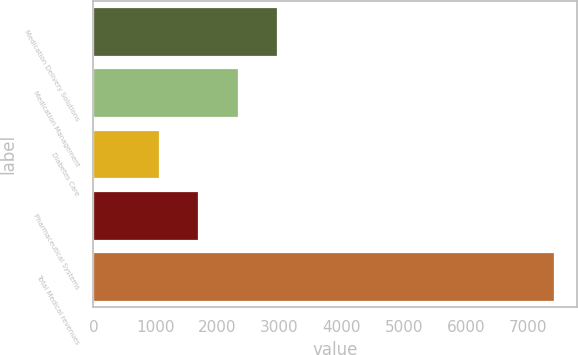Convert chart to OTSL. <chart><loc_0><loc_0><loc_500><loc_500><bar_chart><fcel>Medication Delivery Solutions<fcel>Medication Management<fcel>Diabetes Care<fcel>Pharmaceutical Systems<fcel>Total Medical revenues<nl><fcel>2964.9<fcel>2328.6<fcel>1056<fcel>1692.3<fcel>7419<nl></chart> 